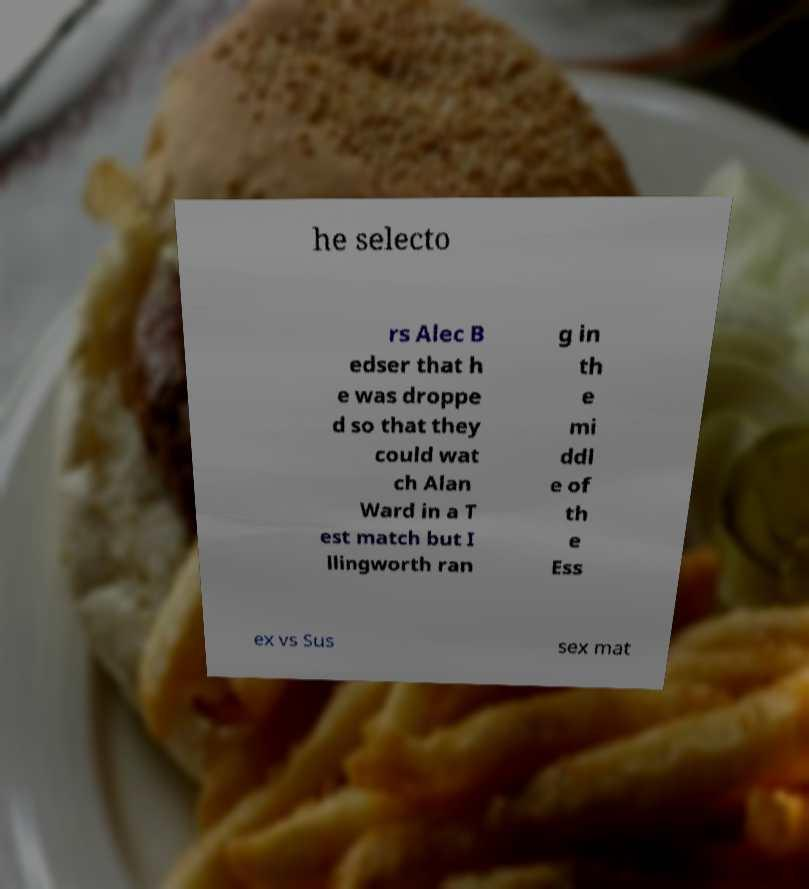For documentation purposes, I need the text within this image transcribed. Could you provide that? he selecto rs Alec B edser that h e was droppe d so that they could wat ch Alan Ward in a T est match but I llingworth ran g in th e mi ddl e of th e Ess ex vs Sus sex mat 